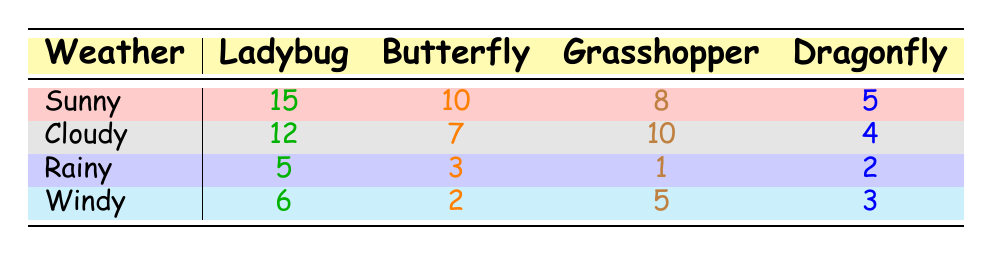What is the total number of Ladybugs caught on Sunny days? Looking at the Sunny row, Ladybugs caught total 15.
Answer: 15 How many Dragonflies were caught on Cloudy days? From the Cloudy row, the number of Dragonflies caught is 4.
Answer: 4 Which weather condition had the highest number of Butterflies caught? The Sunny row shows 10 Butterflies, which is more than Cloudy (7), Rainy (3), and Windy (2). So, Sunny had the highest number.
Answer: Sunny What is the total number of Grasshoppers caught on Rainy and Windy days combined? Rainy has 1 Grasshopper, and Windy has 5 Grasshoppers. Adding these gives 1 + 5 = 6.
Answer: 6 Is it true that more Ladybugs were caught on Cloudy days than on Rainy days? There were 12 Ladybugs caught on Cloudy days and 5 on Rainy days. Since 12 is more than 5, this statement is true.
Answer: Yes What is the average number of Dragonflies caught across all weather conditions? Dragonflies caught are 5 (Sunny) + 4 (Cloudy) + 2 (Rainy) + 3 (Windy) = 14. Dividing by 4 (the number of conditions) gives an average of 14/4 = 3.5.
Answer: 3.5 On which weather condition did we catch fewer total bugs than on Windy days? Windy had a total of Ladybugs (6) + Butterflies (2) + Grasshoppers (5) + Dragonflies (3) = 16. The Rainy days had 5 + 3 + 1 + 2 = 11, which is fewer.
Answer: Rainy What is the difference in the number of Butterflies caught between Sunny and Cloudy days? Sunny had 10 Butterflies and Cloudy had 7. The difference is 10 - 7 = 3.
Answer: 3 Which weather condition had the least number of bugs caught in total? Summing each row: Sunny (15+10+8+5=38), Cloudy (12+7+10+4=33), Rainy (5+3+1+2=11), Windy (6+2+5+3=16). The least total is from Rainy with 11.
Answer: Rainy 